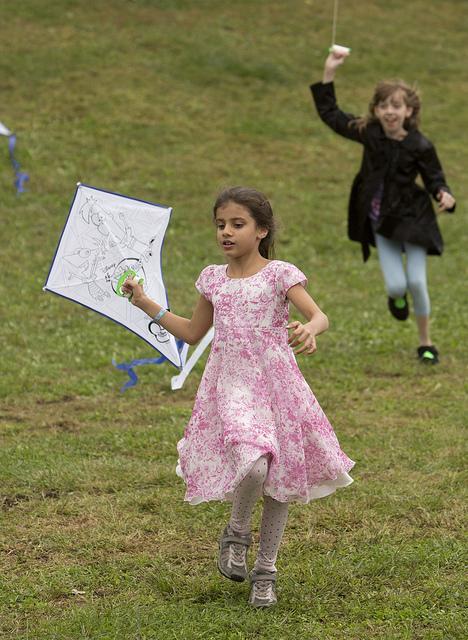How many people are in the photo?
Give a very brief answer. 2. How many kites are there?
Give a very brief answer. 1. 